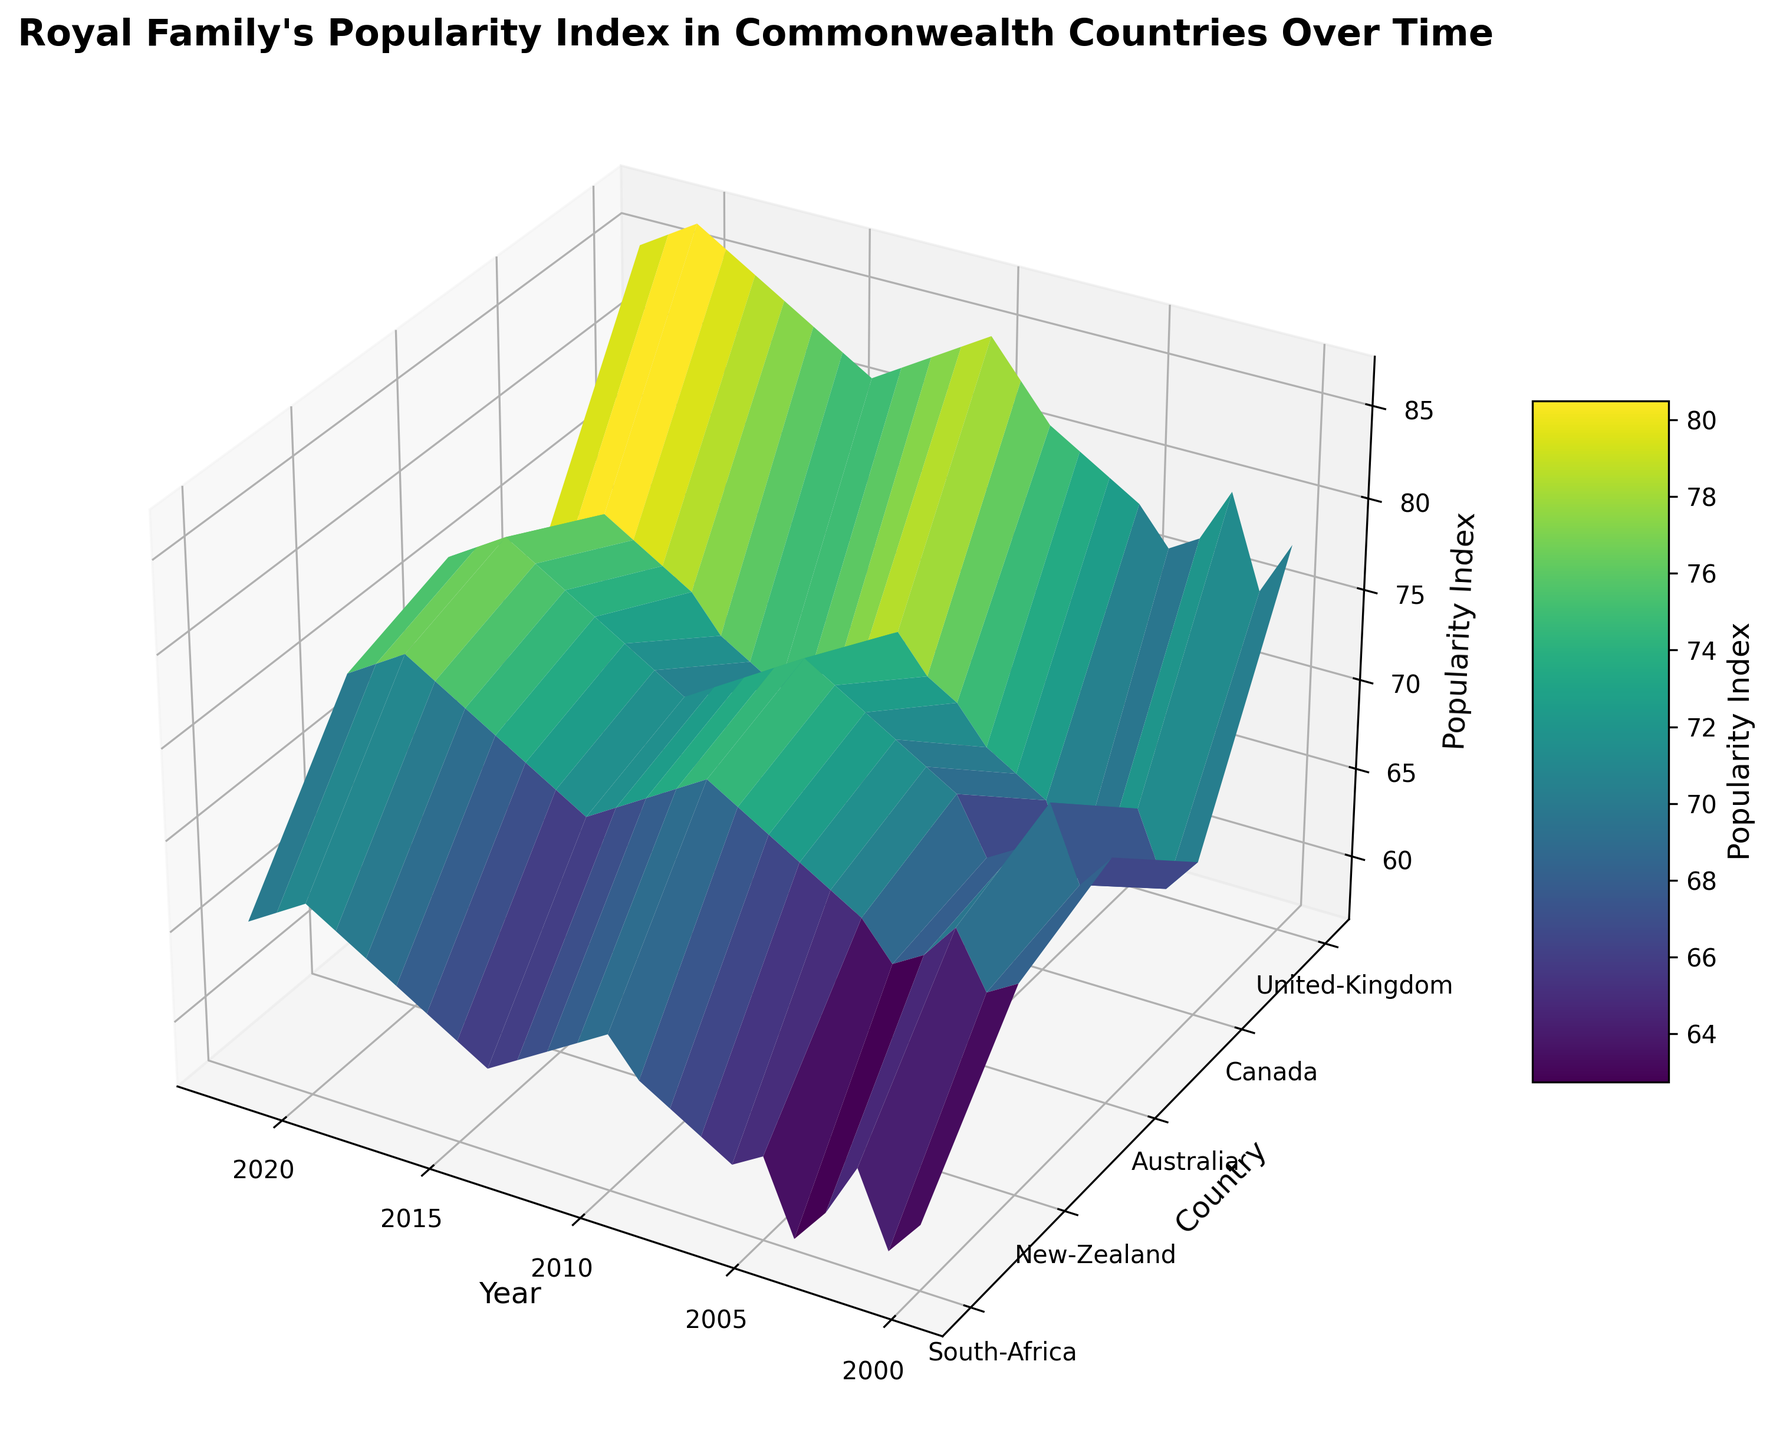What is the highest Popularity Index for any country over the entire period? Observing the surface plot, the highest peak represents the maximum Popularity Index. This occurs for the United Kingdom around the year 2020 with a Popularity Index of 87.
Answer: 87 Which country saw the most significant increase in Popularity Index from 2000 to 2022? To determine this, compare the height differences from 2000 to 2022 for each country in the plot. The United Kingdom shows the largest increase, from 78 in 2000 to 85 in 2022, an increase of 7 points.
Answer: United Kingdom Between Australia and South Africa, which country had a consistently higher Popularity Index? Visually compare the height of the surface for Australia and South Africa across the years. Australia's surface is consistently higher than South Africa's.
Answer: Australia What is the average Popularity Index for Canada from 2000 to 2022? Sum the height values (Popularity Index) for Canada from 2000 to 2022 and divide by the number of years. The sum is (65 + 63 + 67 + 64 + 62 + 66 + 67 + 68 + 70 + 71 + 73 + 72 + 70 + 69 + 68 + 69 + 70 + 72 + 73 + 74 + 75 + 74 + 73) = 1530, divided by 23 (years) gives approximately 66.52.
Answer: 66.52 Which year had the lowest overall Popularity Index across all countries combined? Sum the Popularity Index values for each year across all countries and identify the year with the lowest total. 2004 has the lowest combined Popularity Index: (76 + 62 + 68 + 67 + 57) = 330.
Answer: 2004 In which year did New Zealand's Popularity Index surpass 70 for the first time? Track New Zealand's Popularity Index along the timeline and note the first instance it reaches over 70. This happens in 2002.
Answer: 2002 Comparing 2009 and 2019, which year had a higher Popularity Index for South Africa, and by how much? Find South Africa's Popularity Index for the years 2009 (63) and 2019 (66). The difference is 66 - 63 = 3.
Answer: 2019, by 3 points Which country had the smallest fluctuation in Popularity Index over the given period? Visually inspect the plot to determine which country's surface shows the least vertical variation. Canada's plot appears to have the minimal fluctuation.
Answer: Canada By how much did the Popularity Index for Australia differ between 2010 and 2018? Observe the heights for Australia in 2010 (76) and 2018 (76). The difference is 0.
Answer: 0 